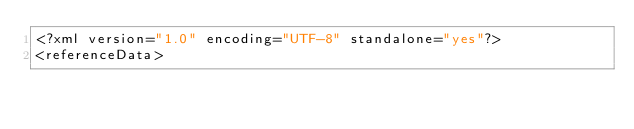Convert code to text. <code><loc_0><loc_0><loc_500><loc_500><_XML_><?xml version="1.0" encoding="UTF-8" standalone="yes"?>
<referenceData></code> 